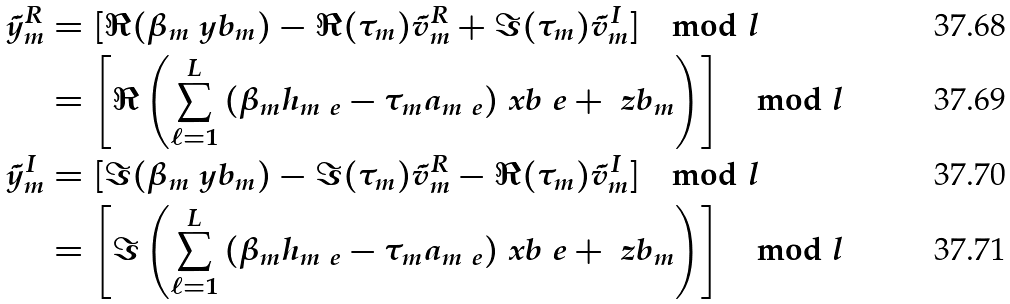<formula> <loc_0><loc_0><loc_500><loc_500>\tilde { y } _ { m } ^ { R } & = [ \Re ( \beta _ { m } \ y b _ { m } ) - \Re ( \tau _ { m } ) \tilde { v } _ { m } ^ { R } + \Im ( \tau _ { m } ) \tilde { v } _ { m } ^ { I } ] \mod l \\ & = \left [ \Re \left ( \sum _ { \ell = 1 } ^ { L } { ( \beta _ { m } { h } _ { m \ e } - \tau _ { m } a _ { m \ e } ) \ x b _ { \ } e } + \ z b _ { m } \right ) \right ] \mod l \\ \tilde { y } _ { m } ^ { I } & = [ \Im ( \beta _ { m } \ y b _ { m } ) - \Im ( \tau _ { m } ) \tilde { v } _ { m } ^ { R } - \Re ( \tau _ { m } ) \tilde { v } _ { m } ^ { I } ] \mod l \\ & = \left [ \Im \left ( \sum _ { \ell = 1 } ^ { L } { ( \beta _ { m } { h } _ { m \ e } - \tau _ { m } a _ { m \ e } ) \ x b _ { \ } e } + \ z b _ { m } \right ) \right ] \mod l</formula> 